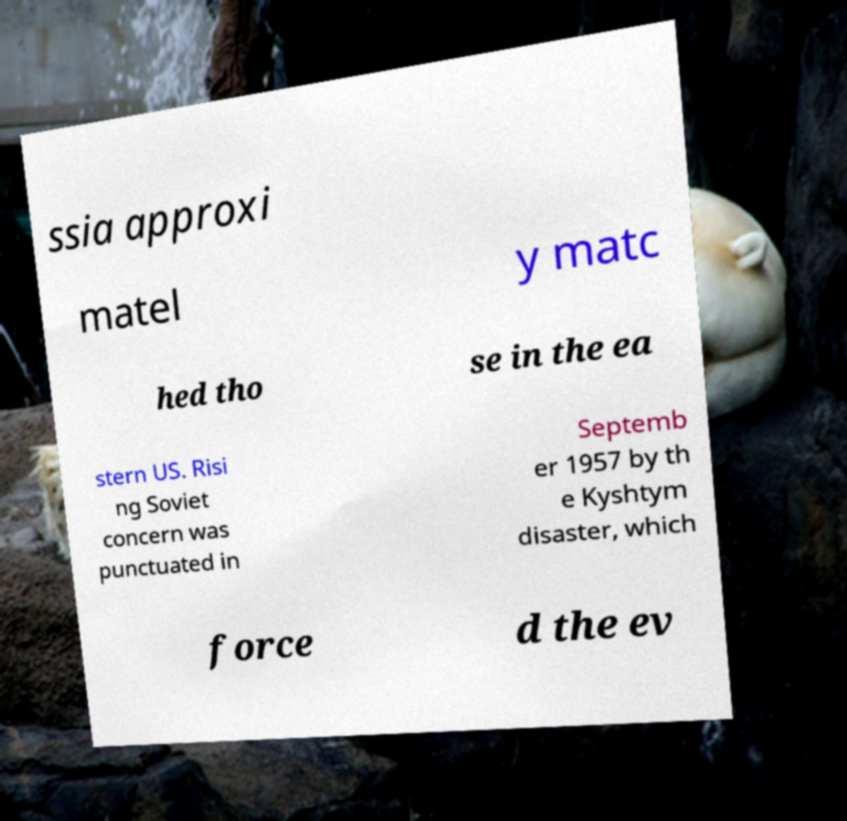What messages or text are displayed in this image? I need them in a readable, typed format. ssia approxi matel y matc hed tho se in the ea stern US. Risi ng Soviet concern was punctuated in Septemb er 1957 by th e Kyshtym disaster, which force d the ev 